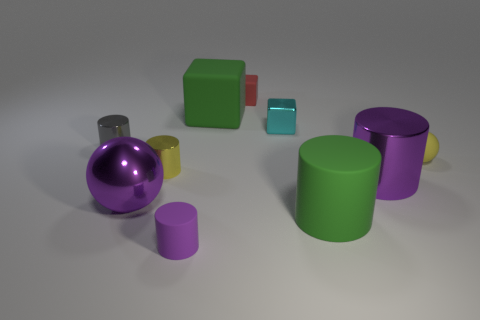Do the big shiny cylinder and the tiny matte cylinder that is left of the tiny cyan shiny thing have the same color?
Make the answer very short. Yes. Is the color of the big matte thing in front of the yellow matte object the same as the large rubber cube?
Offer a terse response. Yes. Is the big green cylinder made of the same material as the big ball?
Your response must be concise. No. Is the number of small gray shiny cylinders that are left of the large rubber cylinder less than the number of big cylinders on the right side of the tiny yellow metallic cylinder?
Make the answer very short. Yes. What is the size of the cylinder that is the same color as the large cube?
Give a very brief answer. Large. What number of cyan metallic objects are to the right of the green matte thing in front of the ball on the right side of the purple matte thing?
Your answer should be very brief. 0. Is the large rubber block the same color as the large matte cylinder?
Keep it short and to the point. Yes. Are there any small shiny objects that have the same color as the tiny matte ball?
Keep it short and to the point. Yes. There is a metallic cube that is the same size as the purple rubber cylinder; what color is it?
Offer a very short reply. Cyan. Is there a big yellow object of the same shape as the tiny red rubber thing?
Ensure brevity in your answer.  No. 